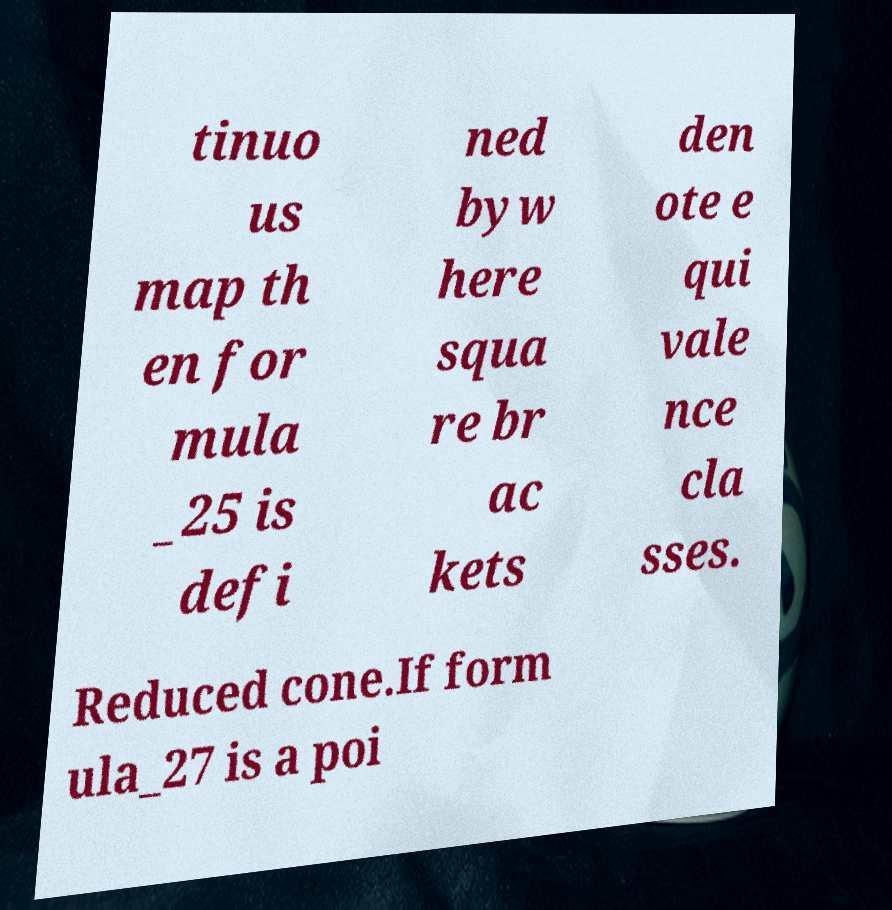What messages or text are displayed in this image? I need them in a readable, typed format. tinuo us map th en for mula _25 is defi ned byw here squa re br ac kets den ote e qui vale nce cla sses. Reduced cone.If form ula_27 is a poi 